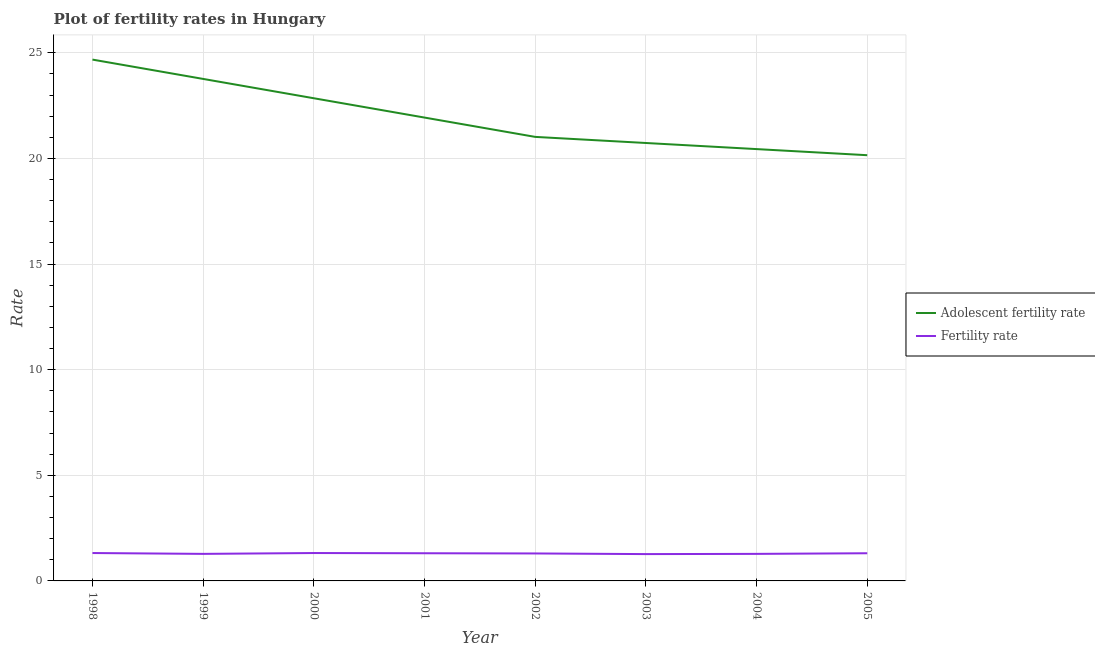How many different coloured lines are there?
Your answer should be compact. 2. Is the number of lines equal to the number of legend labels?
Offer a very short reply. Yes. What is the fertility rate in 2000?
Give a very brief answer. 1.32. Across all years, what is the maximum fertility rate?
Keep it short and to the point. 1.32. Across all years, what is the minimum fertility rate?
Make the answer very short. 1.27. In which year was the fertility rate maximum?
Provide a short and direct response. 1998. In which year was the adolescent fertility rate minimum?
Your response must be concise. 2005. What is the total fertility rate in the graph?
Keep it short and to the point. 10.39. What is the difference between the fertility rate in 2001 and that in 2004?
Provide a succinct answer. 0.03. What is the difference between the fertility rate in 2003 and the adolescent fertility rate in 2001?
Your response must be concise. -20.66. What is the average fertility rate per year?
Your answer should be very brief. 1.3. In the year 1999, what is the difference between the fertility rate and adolescent fertility rate?
Ensure brevity in your answer.  -22.48. What is the ratio of the adolescent fertility rate in 1998 to that in 2002?
Give a very brief answer. 1.17. Is the difference between the fertility rate in 1998 and 2002 greater than the difference between the adolescent fertility rate in 1998 and 2002?
Ensure brevity in your answer.  No. What is the difference between the highest and the second highest adolescent fertility rate?
Offer a very short reply. 0.91. What is the difference between the highest and the lowest adolescent fertility rate?
Provide a short and direct response. 4.53. In how many years, is the fertility rate greater than the average fertility rate taken over all years?
Give a very brief answer. 5. Is the fertility rate strictly greater than the adolescent fertility rate over the years?
Give a very brief answer. No. Is the adolescent fertility rate strictly less than the fertility rate over the years?
Your answer should be compact. No. Does the graph contain any zero values?
Your answer should be compact. No. How are the legend labels stacked?
Offer a very short reply. Vertical. What is the title of the graph?
Your answer should be compact. Plot of fertility rates in Hungary. Does "Research and Development" appear as one of the legend labels in the graph?
Provide a succinct answer. No. What is the label or title of the X-axis?
Your response must be concise. Year. What is the label or title of the Y-axis?
Ensure brevity in your answer.  Rate. What is the Rate of Adolescent fertility rate in 1998?
Make the answer very short. 24.68. What is the Rate in Fertility rate in 1998?
Ensure brevity in your answer.  1.32. What is the Rate in Adolescent fertility rate in 1999?
Your answer should be compact. 23.76. What is the Rate of Fertility rate in 1999?
Provide a succinct answer. 1.28. What is the Rate in Adolescent fertility rate in 2000?
Your answer should be compact. 22.85. What is the Rate in Fertility rate in 2000?
Provide a succinct answer. 1.32. What is the Rate in Adolescent fertility rate in 2001?
Ensure brevity in your answer.  21.93. What is the Rate of Fertility rate in 2001?
Provide a short and direct response. 1.31. What is the Rate in Adolescent fertility rate in 2002?
Provide a succinct answer. 21.02. What is the Rate in Fertility rate in 2002?
Your response must be concise. 1.3. What is the Rate in Adolescent fertility rate in 2003?
Provide a short and direct response. 20.73. What is the Rate in Fertility rate in 2003?
Provide a short and direct response. 1.27. What is the Rate of Adolescent fertility rate in 2004?
Offer a terse response. 20.44. What is the Rate of Fertility rate in 2004?
Provide a short and direct response. 1.28. What is the Rate of Adolescent fertility rate in 2005?
Provide a succinct answer. 20.15. What is the Rate in Fertility rate in 2005?
Give a very brief answer. 1.31. Across all years, what is the maximum Rate of Adolescent fertility rate?
Your answer should be very brief. 24.68. Across all years, what is the maximum Rate of Fertility rate?
Provide a short and direct response. 1.32. Across all years, what is the minimum Rate of Adolescent fertility rate?
Your answer should be very brief. 20.15. Across all years, what is the minimum Rate in Fertility rate?
Your answer should be compact. 1.27. What is the total Rate of Adolescent fertility rate in the graph?
Provide a succinct answer. 175.56. What is the total Rate in Fertility rate in the graph?
Offer a very short reply. 10.39. What is the difference between the Rate of Adolescent fertility rate in 1998 and that in 1999?
Your answer should be compact. 0.91. What is the difference between the Rate of Fertility rate in 1998 and that in 1999?
Your answer should be very brief. 0.04. What is the difference between the Rate in Adolescent fertility rate in 1998 and that in 2000?
Ensure brevity in your answer.  1.83. What is the difference between the Rate of Adolescent fertility rate in 1998 and that in 2001?
Your response must be concise. 2.74. What is the difference between the Rate in Adolescent fertility rate in 1998 and that in 2002?
Your answer should be compact. 3.66. What is the difference between the Rate in Adolescent fertility rate in 1998 and that in 2003?
Offer a terse response. 3.95. What is the difference between the Rate in Adolescent fertility rate in 1998 and that in 2004?
Provide a succinct answer. 4.24. What is the difference between the Rate of Fertility rate in 1998 and that in 2004?
Your answer should be very brief. 0.04. What is the difference between the Rate of Adolescent fertility rate in 1998 and that in 2005?
Keep it short and to the point. 4.53. What is the difference between the Rate of Adolescent fertility rate in 1999 and that in 2000?
Your response must be concise. 0.91. What is the difference between the Rate of Fertility rate in 1999 and that in 2000?
Offer a very short reply. -0.04. What is the difference between the Rate of Adolescent fertility rate in 1999 and that in 2001?
Give a very brief answer. 1.83. What is the difference between the Rate of Fertility rate in 1999 and that in 2001?
Your answer should be very brief. -0.03. What is the difference between the Rate of Adolescent fertility rate in 1999 and that in 2002?
Your response must be concise. 2.74. What is the difference between the Rate of Fertility rate in 1999 and that in 2002?
Offer a terse response. -0.02. What is the difference between the Rate of Adolescent fertility rate in 1999 and that in 2003?
Your response must be concise. 3.03. What is the difference between the Rate of Adolescent fertility rate in 1999 and that in 2004?
Give a very brief answer. 3.32. What is the difference between the Rate of Adolescent fertility rate in 1999 and that in 2005?
Your answer should be very brief. 3.61. What is the difference between the Rate of Fertility rate in 1999 and that in 2005?
Offer a terse response. -0.03. What is the difference between the Rate in Adolescent fertility rate in 2000 and that in 2001?
Your answer should be very brief. 0.91. What is the difference between the Rate in Adolescent fertility rate in 2000 and that in 2002?
Provide a succinct answer. 1.83. What is the difference between the Rate of Adolescent fertility rate in 2000 and that in 2003?
Your answer should be very brief. 2.12. What is the difference between the Rate in Adolescent fertility rate in 2000 and that in 2004?
Ensure brevity in your answer.  2.41. What is the difference between the Rate of Adolescent fertility rate in 2000 and that in 2005?
Your answer should be compact. 2.7. What is the difference between the Rate of Adolescent fertility rate in 2001 and that in 2002?
Make the answer very short. 0.91. What is the difference between the Rate in Fertility rate in 2001 and that in 2002?
Offer a terse response. 0.01. What is the difference between the Rate in Adolescent fertility rate in 2001 and that in 2003?
Make the answer very short. 1.2. What is the difference between the Rate of Fertility rate in 2001 and that in 2003?
Ensure brevity in your answer.  0.04. What is the difference between the Rate of Adolescent fertility rate in 2001 and that in 2004?
Provide a short and direct response. 1.49. What is the difference between the Rate of Adolescent fertility rate in 2001 and that in 2005?
Make the answer very short. 1.78. What is the difference between the Rate in Fertility rate in 2001 and that in 2005?
Make the answer very short. 0. What is the difference between the Rate of Adolescent fertility rate in 2002 and that in 2003?
Give a very brief answer. 0.29. What is the difference between the Rate of Fertility rate in 2002 and that in 2003?
Offer a very short reply. 0.03. What is the difference between the Rate of Adolescent fertility rate in 2002 and that in 2004?
Make the answer very short. 0.58. What is the difference between the Rate of Fertility rate in 2002 and that in 2004?
Your answer should be very brief. 0.02. What is the difference between the Rate of Adolescent fertility rate in 2002 and that in 2005?
Keep it short and to the point. 0.87. What is the difference between the Rate of Fertility rate in 2002 and that in 2005?
Keep it short and to the point. -0.01. What is the difference between the Rate of Adolescent fertility rate in 2003 and that in 2004?
Ensure brevity in your answer.  0.29. What is the difference between the Rate of Fertility rate in 2003 and that in 2004?
Offer a very short reply. -0.01. What is the difference between the Rate of Adolescent fertility rate in 2003 and that in 2005?
Keep it short and to the point. 0.58. What is the difference between the Rate of Fertility rate in 2003 and that in 2005?
Keep it short and to the point. -0.04. What is the difference between the Rate in Adolescent fertility rate in 2004 and that in 2005?
Give a very brief answer. 0.29. What is the difference between the Rate in Fertility rate in 2004 and that in 2005?
Provide a succinct answer. -0.03. What is the difference between the Rate in Adolescent fertility rate in 1998 and the Rate in Fertility rate in 1999?
Provide a succinct answer. 23.4. What is the difference between the Rate in Adolescent fertility rate in 1998 and the Rate in Fertility rate in 2000?
Provide a succinct answer. 23.36. What is the difference between the Rate of Adolescent fertility rate in 1998 and the Rate of Fertility rate in 2001?
Keep it short and to the point. 23.37. What is the difference between the Rate of Adolescent fertility rate in 1998 and the Rate of Fertility rate in 2002?
Make the answer very short. 23.38. What is the difference between the Rate in Adolescent fertility rate in 1998 and the Rate in Fertility rate in 2003?
Offer a very short reply. 23.41. What is the difference between the Rate of Adolescent fertility rate in 1998 and the Rate of Fertility rate in 2004?
Your answer should be very brief. 23.4. What is the difference between the Rate in Adolescent fertility rate in 1998 and the Rate in Fertility rate in 2005?
Your answer should be very brief. 23.37. What is the difference between the Rate in Adolescent fertility rate in 1999 and the Rate in Fertility rate in 2000?
Provide a short and direct response. 22.44. What is the difference between the Rate in Adolescent fertility rate in 1999 and the Rate in Fertility rate in 2001?
Provide a succinct answer. 22.45. What is the difference between the Rate of Adolescent fertility rate in 1999 and the Rate of Fertility rate in 2002?
Make the answer very short. 22.46. What is the difference between the Rate in Adolescent fertility rate in 1999 and the Rate in Fertility rate in 2003?
Your response must be concise. 22.49. What is the difference between the Rate in Adolescent fertility rate in 1999 and the Rate in Fertility rate in 2004?
Your answer should be compact. 22.48. What is the difference between the Rate of Adolescent fertility rate in 1999 and the Rate of Fertility rate in 2005?
Your response must be concise. 22.45. What is the difference between the Rate in Adolescent fertility rate in 2000 and the Rate in Fertility rate in 2001?
Your answer should be compact. 21.54. What is the difference between the Rate in Adolescent fertility rate in 2000 and the Rate in Fertility rate in 2002?
Ensure brevity in your answer.  21.55. What is the difference between the Rate in Adolescent fertility rate in 2000 and the Rate in Fertility rate in 2003?
Your response must be concise. 21.58. What is the difference between the Rate in Adolescent fertility rate in 2000 and the Rate in Fertility rate in 2004?
Your answer should be compact. 21.57. What is the difference between the Rate of Adolescent fertility rate in 2000 and the Rate of Fertility rate in 2005?
Provide a short and direct response. 21.54. What is the difference between the Rate in Adolescent fertility rate in 2001 and the Rate in Fertility rate in 2002?
Your answer should be very brief. 20.63. What is the difference between the Rate in Adolescent fertility rate in 2001 and the Rate in Fertility rate in 2003?
Provide a short and direct response. 20.66. What is the difference between the Rate of Adolescent fertility rate in 2001 and the Rate of Fertility rate in 2004?
Ensure brevity in your answer.  20.65. What is the difference between the Rate of Adolescent fertility rate in 2001 and the Rate of Fertility rate in 2005?
Ensure brevity in your answer.  20.62. What is the difference between the Rate in Adolescent fertility rate in 2002 and the Rate in Fertility rate in 2003?
Your response must be concise. 19.75. What is the difference between the Rate of Adolescent fertility rate in 2002 and the Rate of Fertility rate in 2004?
Your answer should be compact. 19.74. What is the difference between the Rate in Adolescent fertility rate in 2002 and the Rate in Fertility rate in 2005?
Make the answer very short. 19.71. What is the difference between the Rate in Adolescent fertility rate in 2003 and the Rate in Fertility rate in 2004?
Provide a short and direct response. 19.45. What is the difference between the Rate in Adolescent fertility rate in 2003 and the Rate in Fertility rate in 2005?
Keep it short and to the point. 19.42. What is the difference between the Rate of Adolescent fertility rate in 2004 and the Rate of Fertility rate in 2005?
Ensure brevity in your answer.  19.13. What is the average Rate in Adolescent fertility rate per year?
Your answer should be very brief. 21.94. What is the average Rate in Fertility rate per year?
Give a very brief answer. 1.3. In the year 1998, what is the difference between the Rate in Adolescent fertility rate and Rate in Fertility rate?
Your response must be concise. 23.36. In the year 1999, what is the difference between the Rate in Adolescent fertility rate and Rate in Fertility rate?
Keep it short and to the point. 22.48. In the year 2000, what is the difference between the Rate in Adolescent fertility rate and Rate in Fertility rate?
Your response must be concise. 21.53. In the year 2001, what is the difference between the Rate of Adolescent fertility rate and Rate of Fertility rate?
Keep it short and to the point. 20.62. In the year 2002, what is the difference between the Rate of Adolescent fertility rate and Rate of Fertility rate?
Provide a short and direct response. 19.72. In the year 2003, what is the difference between the Rate in Adolescent fertility rate and Rate in Fertility rate?
Give a very brief answer. 19.46. In the year 2004, what is the difference between the Rate in Adolescent fertility rate and Rate in Fertility rate?
Offer a terse response. 19.16. In the year 2005, what is the difference between the Rate in Adolescent fertility rate and Rate in Fertility rate?
Offer a very short reply. 18.84. What is the ratio of the Rate in Adolescent fertility rate in 1998 to that in 1999?
Offer a terse response. 1.04. What is the ratio of the Rate of Fertility rate in 1998 to that in 1999?
Provide a succinct answer. 1.03. What is the ratio of the Rate of Adolescent fertility rate in 1998 to that in 2000?
Keep it short and to the point. 1.08. What is the ratio of the Rate in Adolescent fertility rate in 1998 to that in 2001?
Provide a succinct answer. 1.13. What is the ratio of the Rate in Fertility rate in 1998 to that in 2001?
Offer a terse response. 1.01. What is the ratio of the Rate of Adolescent fertility rate in 1998 to that in 2002?
Your answer should be compact. 1.17. What is the ratio of the Rate of Fertility rate in 1998 to that in 2002?
Provide a short and direct response. 1.02. What is the ratio of the Rate of Adolescent fertility rate in 1998 to that in 2003?
Make the answer very short. 1.19. What is the ratio of the Rate of Fertility rate in 1998 to that in 2003?
Your response must be concise. 1.04. What is the ratio of the Rate in Adolescent fertility rate in 1998 to that in 2004?
Offer a terse response. 1.21. What is the ratio of the Rate of Fertility rate in 1998 to that in 2004?
Offer a very short reply. 1.03. What is the ratio of the Rate of Adolescent fertility rate in 1998 to that in 2005?
Make the answer very short. 1.22. What is the ratio of the Rate of Fertility rate in 1998 to that in 2005?
Keep it short and to the point. 1.01. What is the ratio of the Rate in Fertility rate in 1999 to that in 2000?
Make the answer very short. 0.97. What is the ratio of the Rate in Adolescent fertility rate in 1999 to that in 2001?
Your answer should be very brief. 1.08. What is the ratio of the Rate in Fertility rate in 1999 to that in 2001?
Make the answer very short. 0.98. What is the ratio of the Rate of Adolescent fertility rate in 1999 to that in 2002?
Your answer should be very brief. 1.13. What is the ratio of the Rate of Fertility rate in 1999 to that in 2002?
Your answer should be compact. 0.98. What is the ratio of the Rate in Adolescent fertility rate in 1999 to that in 2003?
Your answer should be very brief. 1.15. What is the ratio of the Rate of Fertility rate in 1999 to that in 2003?
Provide a short and direct response. 1.01. What is the ratio of the Rate of Adolescent fertility rate in 1999 to that in 2004?
Your response must be concise. 1.16. What is the ratio of the Rate in Adolescent fertility rate in 1999 to that in 2005?
Provide a succinct answer. 1.18. What is the ratio of the Rate in Fertility rate in 1999 to that in 2005?
Provide a short and direct response. 0.98. What is the ratio of the Rate in Adolescent fertility rate in 2000 to that in 2001?
Offer a very short reply. 1.04. What is the ratio of the Rate of Fertility rate in 2000 to that in 2001?
Provide a short and direct response. 1.01. What is the ratio of the Rate in Adolescent fertility rate in 2000 to that in 2002?
Make the answer very short. 1.09. What is the ratio of the Rate in Fertility rate in 2000 to that in 2002?
Your response must be concise. 1.02. What is the ratio of the Rate of Adolescent fertility rate in 2000 to that in 2003?
Make the answer very short. 1.1. What is the ratio of the Rate in Fertility rate in 2000 to that in 2003?
Your response must be concise. 1.04. What is the ratio of the Rate in Adolescent fertility rate in 2000 to that in 2004?
Keep it short and to the point. 1.12. What is the ratio of the Rate of Fertility rate in 2000 to that in 2004?
Provide a short and direct response. 1.03. What is the ratio of the Rate in Adolescent fertility rate in 2000 to that in 2005?
Give a very brief answer. 1.13. What is the ratio of the Rate of Fertility rate in 2000 to that in 2005?
Provide a short and direct response. 1.01. What is the ratio of the Rate in Adolescent fertility rate in 2001 to that in 2002?
Make the answer very short. 1.04. What is the ratio of the Rate in Fertility rate in 2001 to that in 2002?
Give a very brief answer. 1.01. What is the ratio of the Rate in Adolescent fertility rate in 2001 to that in 2003?
Offer a very short reply. 1.06. What is the ratio of the Rate in Fertility rate in 2001 to that in 2003?
Your response must be concise. 1.03. What is the ratio of the Rate of Adolescent fertility rate in 2001 to that in 2004?
Provide a succinct answer. 1.07. What is the ratio of the Rate of Fertility rate in 2001 to that in 2004?
Your response must be concise. 1.02. What is the ratio of the Rate of Adolescent fertility rate in 2001 to that in 2005?
Keep it short and to the point. 1.09. What is the ratio of the Rate in Adolescent fertility rate in 2002 to that in 2003?
Make the answer very short. 1.01. What is the ratio of the Rate of Fertility rate in 2002 to that in 2003?
Offer a terse response. 1.02. What is the ratio of the Rate of Adolescent fertility rate in 2002 to that in 2004?
Your answer should be compact. 1.03. What is the ratio of the Rate in Fertility rate in 2002 to that in 2004?
Make the answer very short. 1.02. What is the ratio of the Rate of Adolescent fertility rate in 2002 to that in 2005?
Make the answer very short. 1.04. What is the ratio of the Rate of Fertility rate in 2002 to that in 2005?
Your answer should be very brief. 0.99. What is the ratio of the Rate in Adolescent fertility rate in 2003 to that in 2004?
Provide a short and direct response. 1.01. What is the ratio of the Rate of Adolescent fertility rate in 2003 to that in 2005?
Your answer should be very brief. 1.03. What is the ratio of the Rate in Fertility rate in 2003 to that in 2005?
Provide a succinct answer. 0.97. What is the ratio of the Rate in Adolescent fertility rate in 2004 to that in 2005?
Ensure brevity in your answer.  1.01. What is the ratio of the Rate in Fertility rate in 2004 to that in 2005?
Your answer should be very brief. 0.98. What is the difference between the highest and the second highest Rate in Adolescent fertility rate?
Provide a short and direct response. 0.91. What is the difference between the highest and the second highest Rate in Fertility rate?
Provide a succinct answer. 0. What is the difference between the highest and the lowest Rate in Adolescent fertility rate?
Your answer should be very brief. 4.53. 